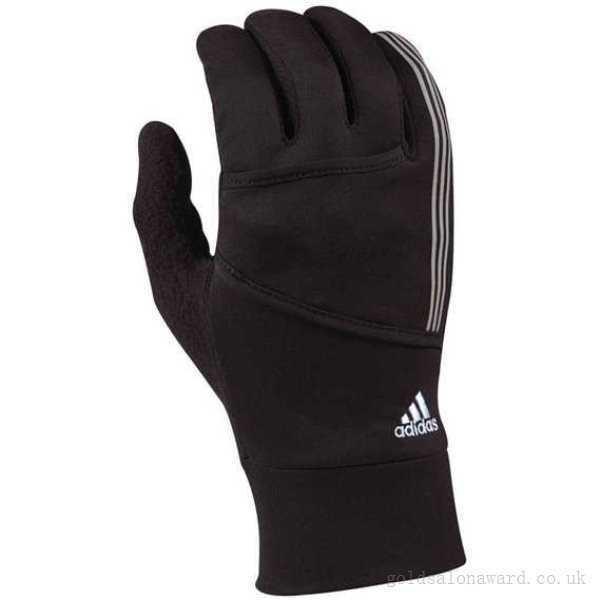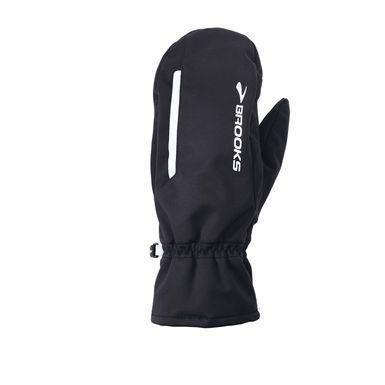The first image is the image on the left, the second image is the image on the right. Evaluate the accuracy of this statement regarding the images: "None of the gloves or mittens make a pair.". Is it true? Answer yes or no. Yes. The first image is the image on the left, the second image is the image on the right. Evaluate the accuracy of this statement regarding the images: "One image contains a pair of white and dark two-toned gloves, and the other contains a single glove.". Is it true? Answer yes or no. No. 